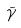Convert formula to latex. <formula><loc_0><loc_0><loc_500><loc_500>\tilde { \gamma }</formula> 